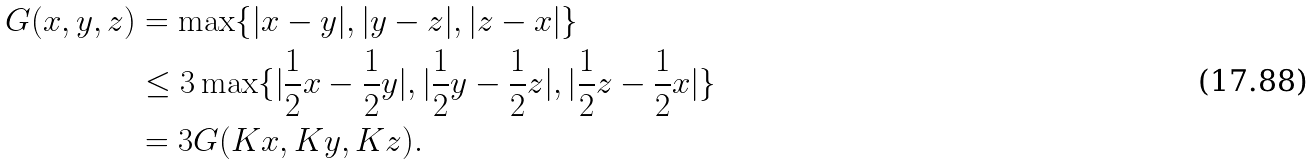Convert formula to latex. <formula><loc_0><loc_0><loc_500><loc_500>G ( x , y , z ) & = \max \{ | x - y | , | y - z | , | z - x | \} \\ & \leq 3 \max \{ | \frac { 1 } { 2 } x - \frac { 1 } { 2 } y | , | \frac { 1 } { 2 } y - \frac { 1 } { 2 } z | , | \frac { 1 } { 2 } z - \frac { 1 } { 2 } x | \} \\ & = 3 G ( K x , K y , K z ) .</formula> 